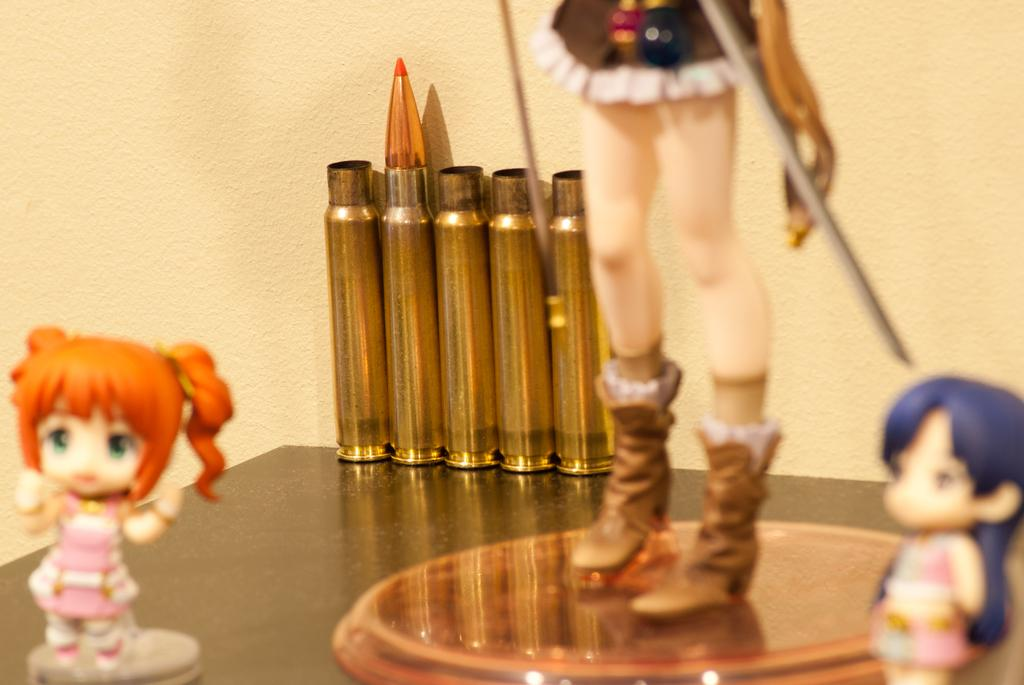What type of objects can be seen in the image? There are toys and gold-colored objects in the image. Where are the toys and gold-colored objects placed? They are placed on a surface. What can be seen in the background of the image? There is a wall in the background of the image. How many goats are tied in a knot in the image? There are no goats or knots present in the image. 